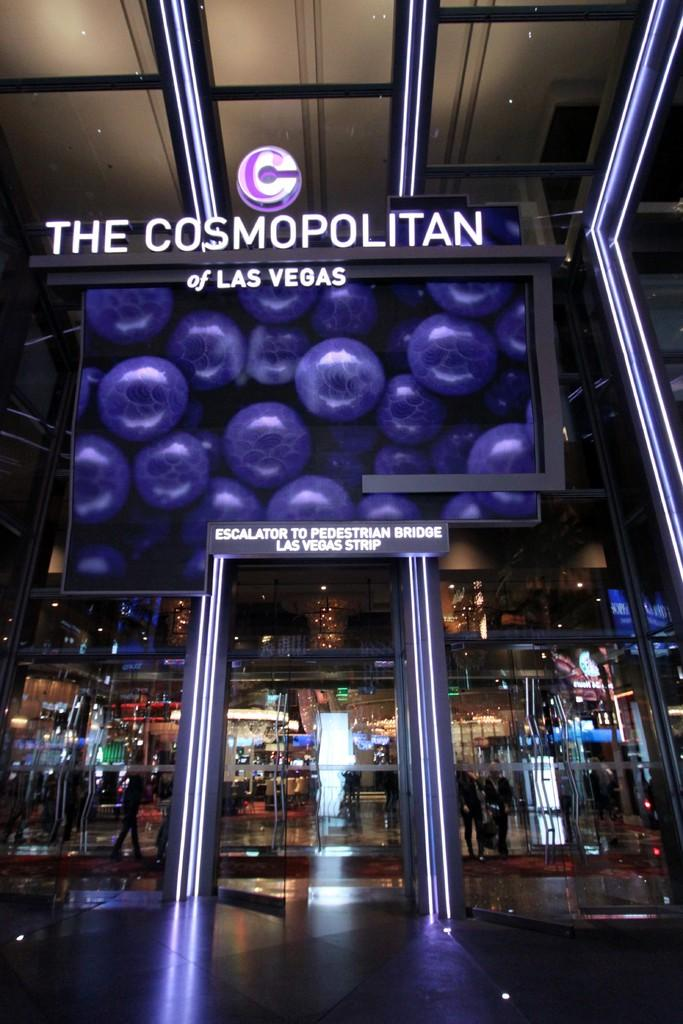<image>
Provide a brief description of the given image. a sign for The Cosmopolitan of Las Vegas with a purple monitor 